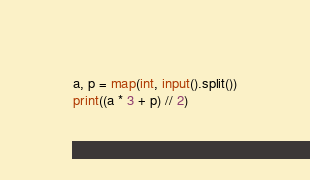<code> <loc_0><loc_0><loc_500><loc_500><_Python_>a, p = map(int, input().split())
print((a * 3 + p) // 2)</code> 